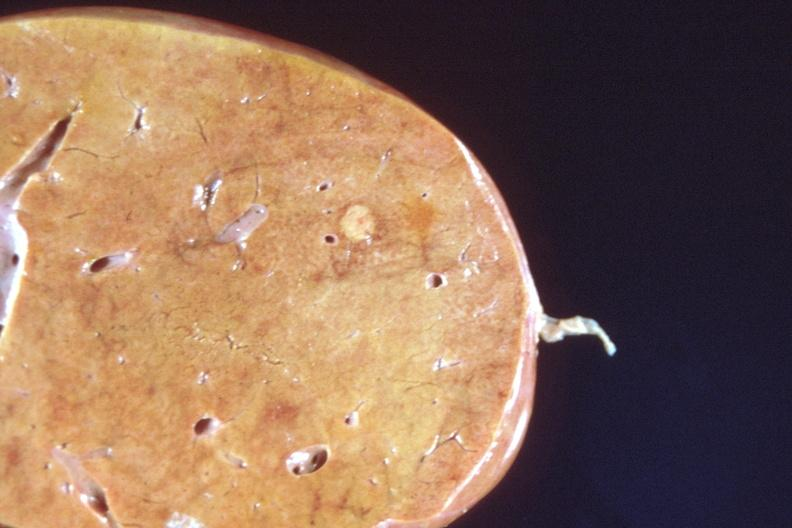what does this image show?
Answer the question using a single word or phrase. Liver 